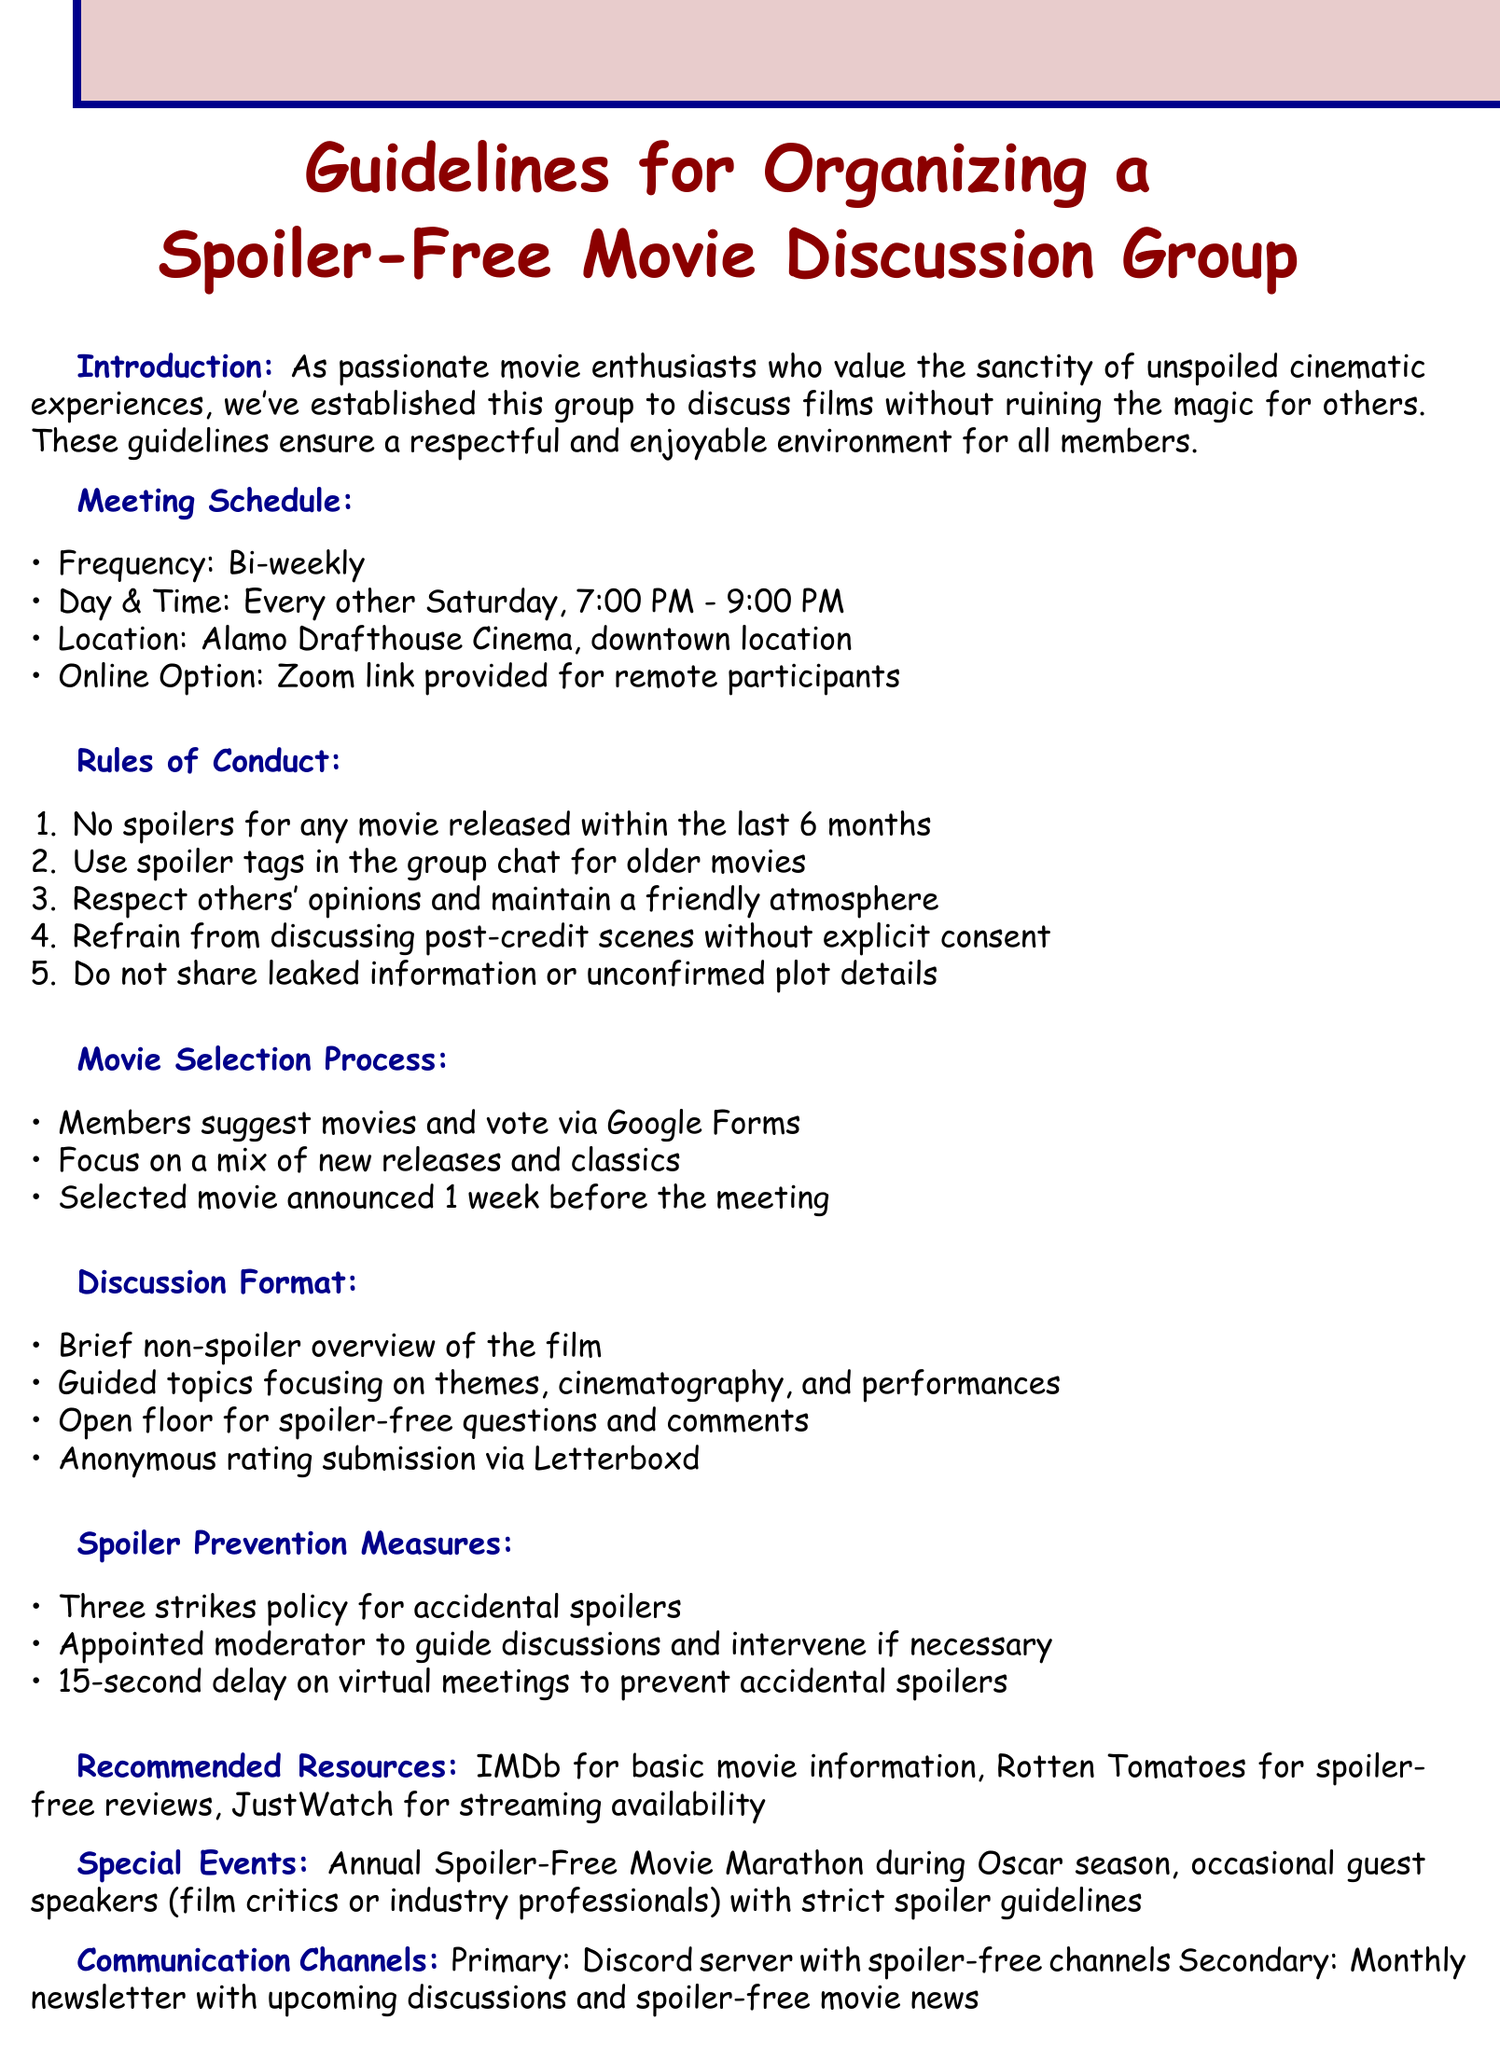What is the meeting frequency? The document states that the meetings are held bi-weekly.
Answer: Bi-weekly What day are the meetings scheduled? The meetings take place every other Saturday as per the schedule given in the document.
Answer: Every other Saturday How long does each meeting last? The duration of each meeting is mentioned in the document as 2 hours.
Answer: 2 hours What is the policy for sharing spoilers? The document outlines a specific rule against spoilers for any movie released within the last 6 months.
Answer: No spoilers for any movie released within the last 6 months What is the movie selection announcement timeframe? The announcement regarding the selected movie is made one week before the meeting, as stated in the document.
Answer: 1 week What method is used for voting on movies? Members suggest movies and vote through Google Forms, according to the document.
Answer: Google Forms What is the purpose of the Discord server mentioned? The Discord server is designed for communication among members with spoiler-free channels, as outlined in the document.
Answer: Spoiler-free channels What happens if someone accidentally shares a spoiler? The document mentions a three strikes policy for accidental spoilers among the rules.
Answer: Three strikes policy What type of reviews is recommended for checking before discussions? The document suggests using Rotten Tomatoes for spoiler-free reviews.
Answer: Spoiler-free reviews 